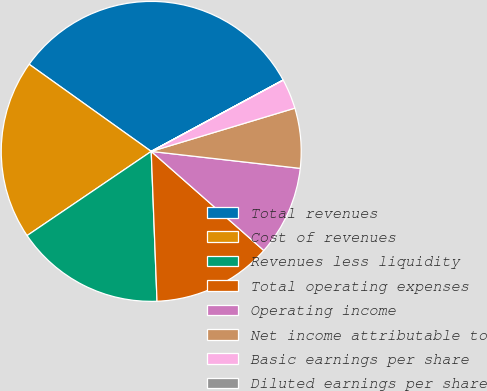Convert chart to OTSL. <chart><loc_0><loc_0><loc_500><loc_500><pie_chart><fcel>Total revenues<fcel>Cost of revenues<fcel>Revenues less liquidity<fcel>Total operating expenses<fcel>Operating income<fcel>Net income attributable to<fcel>Basic earnings per share<fcel>Diluted earnings per share<nl><fcel>32.24%<fcel>19.35%<fcel>16.13%<fcel>12.9%<fcel>9.68%<fcel>6.46%<fcel>3.23%<fcel>0.01%<nl></chart> 